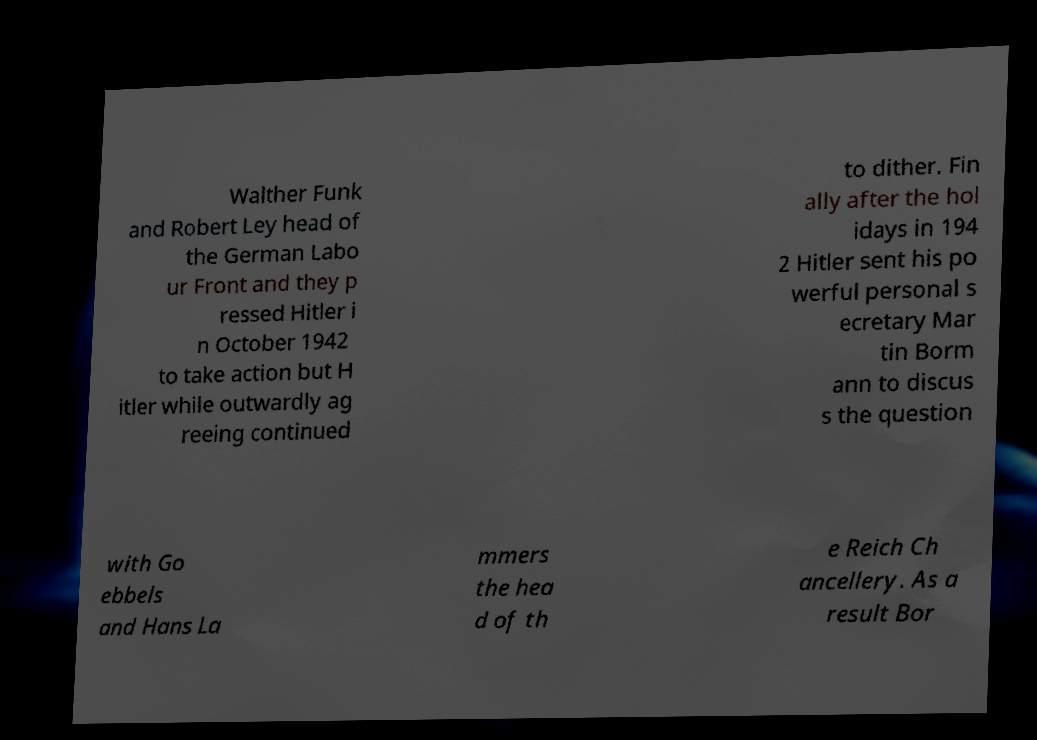Please identify and transcribe the text found in this image. Walther Funk and Robert Ley head of the German Labo ur Front and they p ressed Hitler i n October 1942 to take action but H itler while outwardly ag reeing continued to dither. Fin ally after the hol idays in 194 2 Hitler sent his po werful personal s ecretary Mar tin Borm ann to discus s the question with Go ebbels and Hans La mmers the hea d of th e Reich Ch ancellery. As a result Bor 